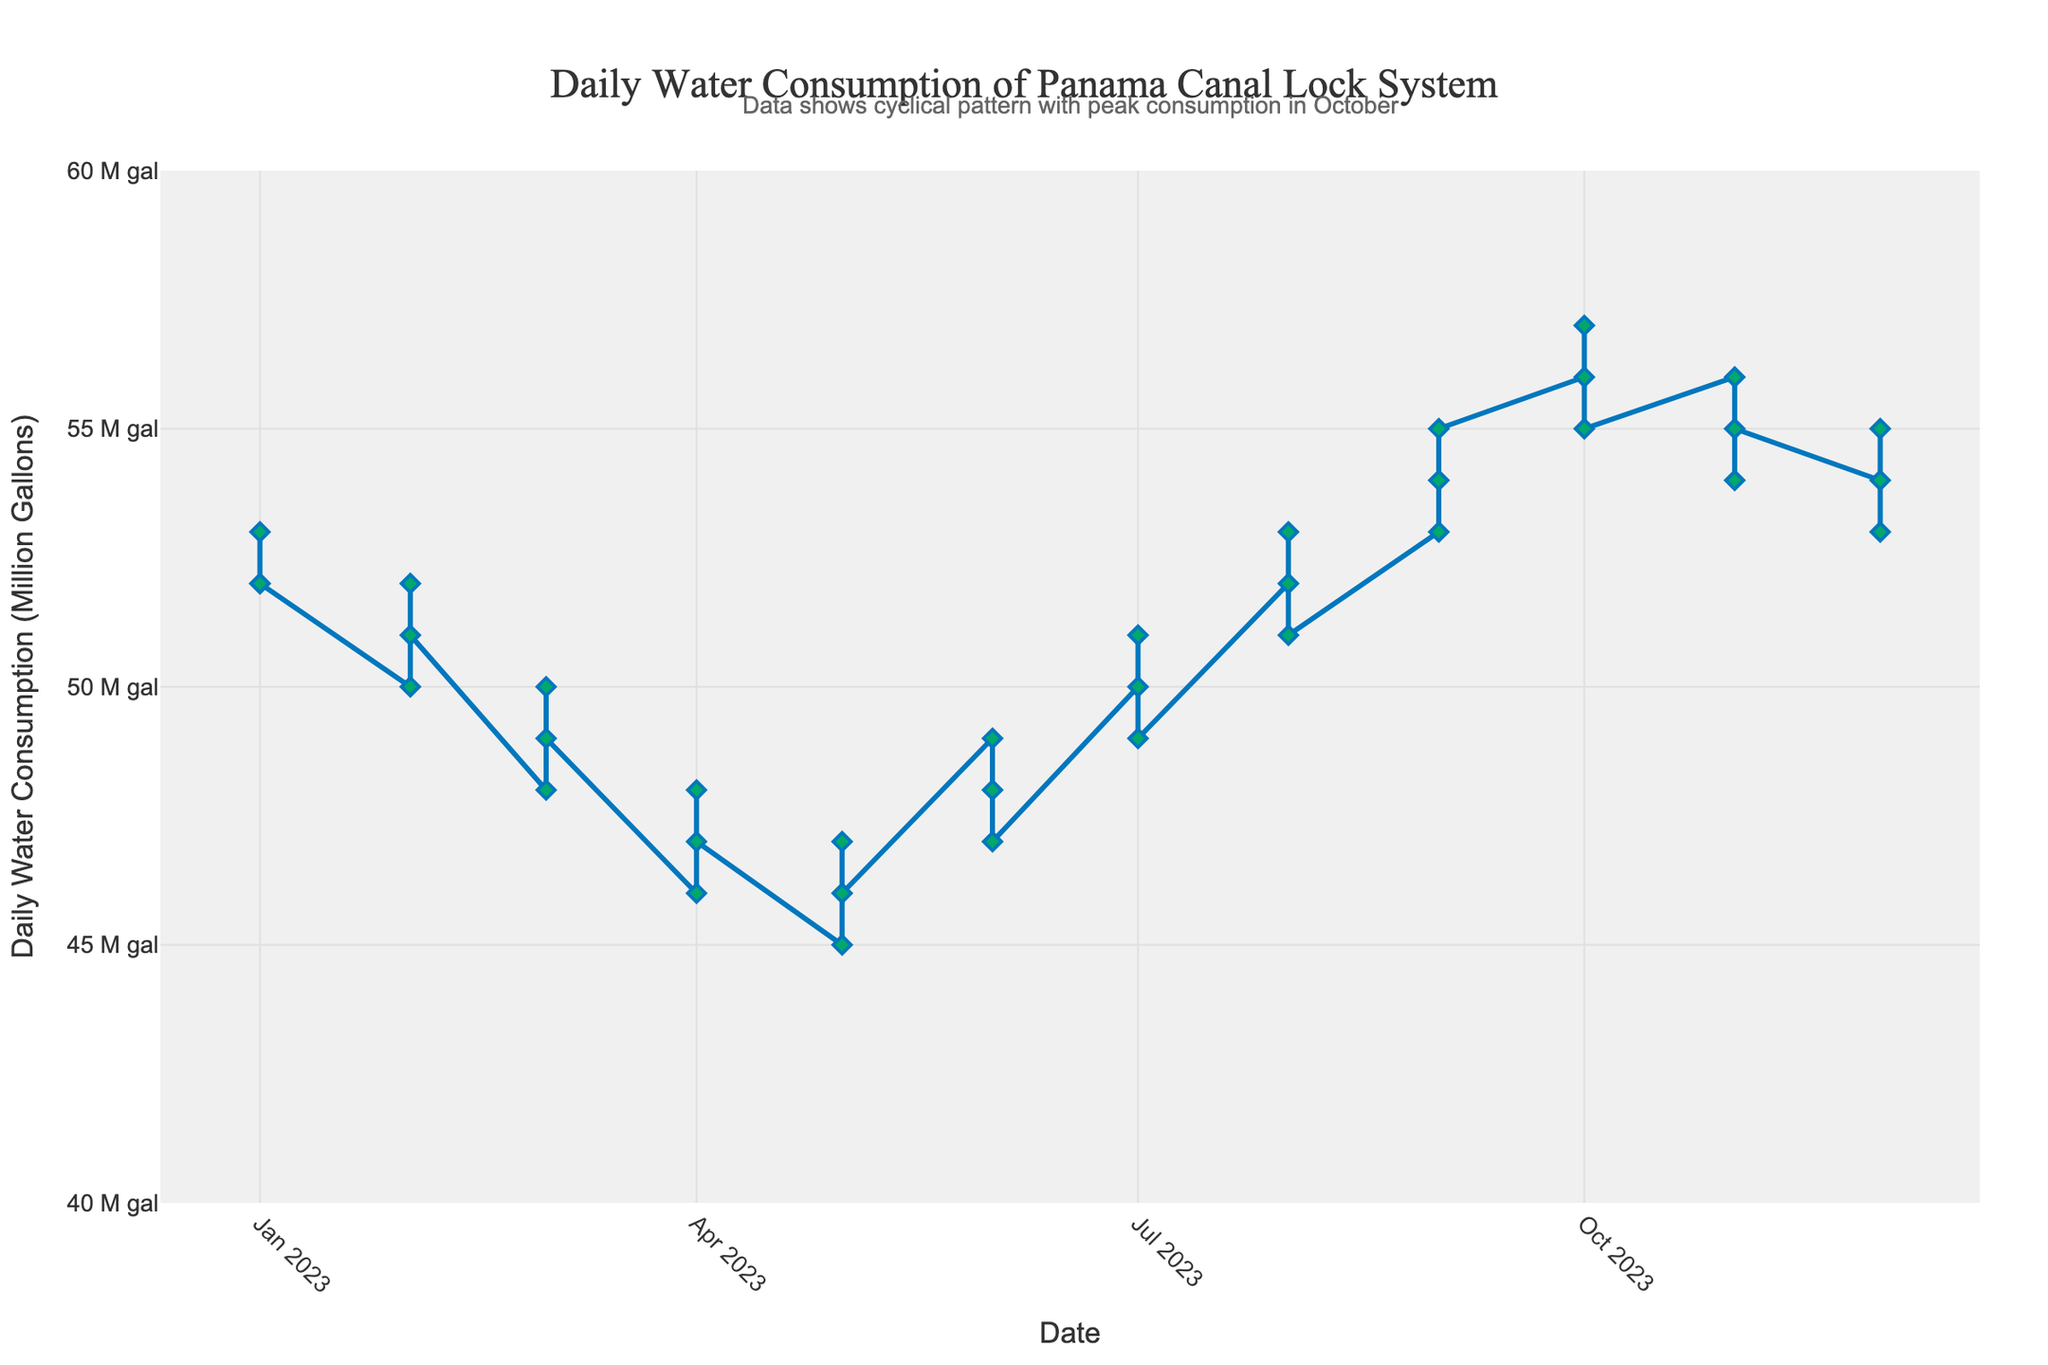What month has the highest daily water consumption? The highest daily water consumption is in October, reaching 57 million gallons.
Answer: October What is the difference in daily water consumption between February and June in the second year? In the second year, February has 51 million gallons and June has 48 million gallons. The difference is 51 - 48 = 3 million gallons.
Answer: 3 million gallons In which month does the daily water consumption start increasing again after May? After May, the consumption starts increasing in June.
Answer: June What is the average daily water consumption over the three consecutive years? Sum the daily water consumption values from all three years and then divide by the total number of months: (52+50+...+55)/36. The average is approximately 51.39 million gallons.
Answer: 51.39 million gallons Which period shows the most consistent daily water consumption? September to December shows the most consistent daily water consumption, with values of 53, 54, and 55 in one year, and 54, 55, and 56 in another year.
Answer: September to December How does the daily water consumption trend change from August to October? The consumption increases from 51 million gallons in August to 53 million gallons in September, and peaks at 55 million gallons in October.
Answer: Increases During the years shown, how many times did the daily water consumption peak in October? By observing the chart, the consumption peaks in October across all three years.
Answer: 3 times What is the total daily water consumption for the month of April over the three years? Sum the consumption values for April in each of the three years: 46 + 47 + 48 = 141 million gallons.
Answer: 141 million gallons Compare the daily water consumption for July in the first and last year. Which year had higher consumption? In the first year, July has 49 million gallons. In the last year, July has 51 million gallons. The last year had higher consumption.
Answer: Last year 